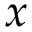<formula> <loc_0><loc_0><loc_500><loc_500>x</formula> 